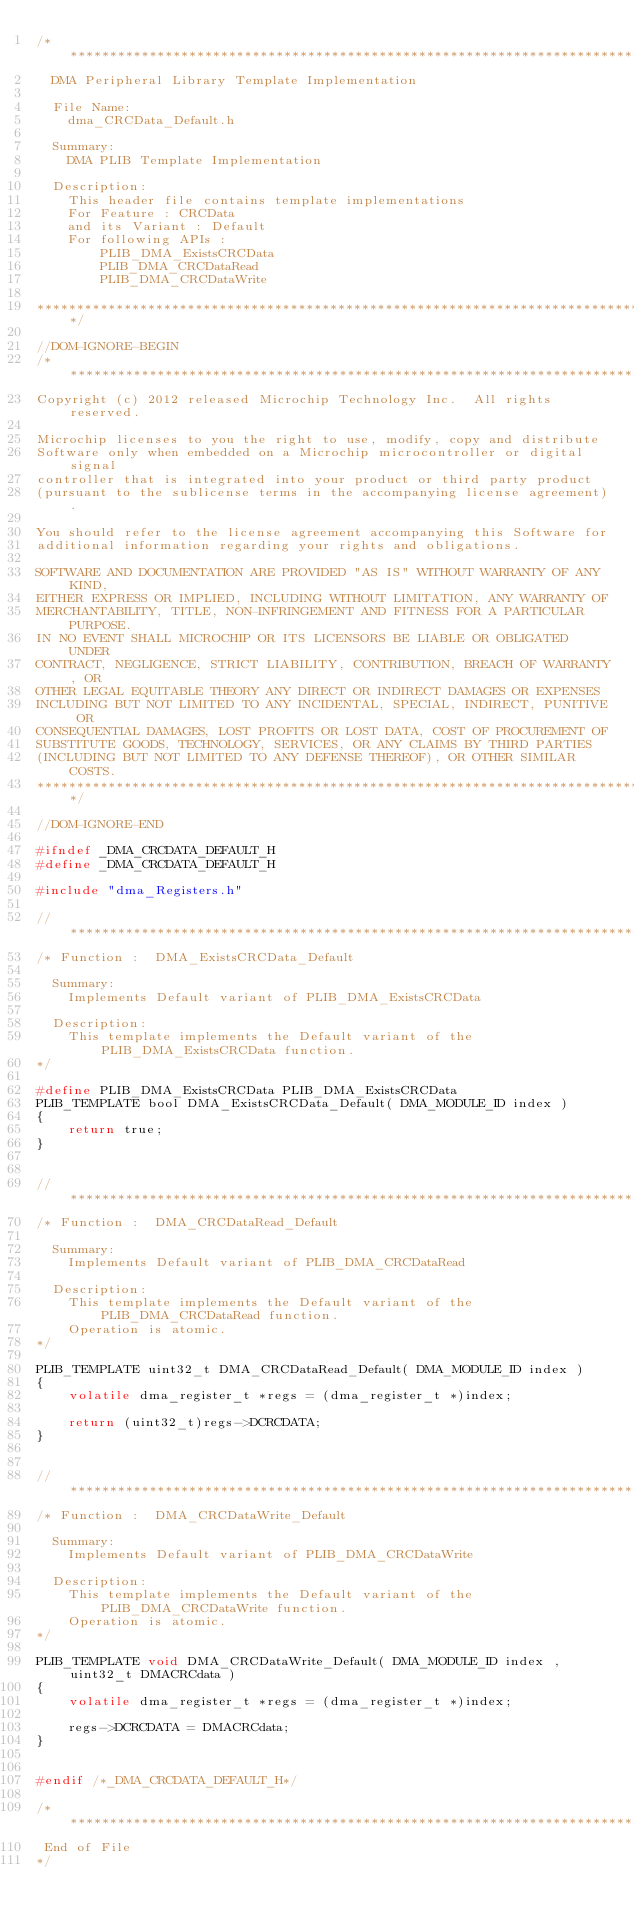Convert code to text. <code><loc_0><loc_0><loc_500><loc_500><_C_>/*******************************************************************************
  DMA Peripheral Library Template Implementation

  File Name:
    dma_CRCData_Default.h

  Summary:
    DMA PLIB Template Implementation

  Description:
    This header file contains template implementations
    For Feature : CRCData
    and its Variant : Default
    For following APIs :
        PLIB_DMA_ExistsCRCData
        PLIB_DMA_CRCDataRead
        PLIB_DMA_CRCDataWrite

*******************************************************************************/

//DOM-IGNORE-BEGIN
/*******************************************************************************
Copyright (c) 2012 released Microchip Technology Inc.  All rights reserved.

Microchip licenses to you the right to use, modify, copy and distribute
Software only when embedded on a Microchip microcontroller or digital signal
controller that is integrated into your product or third party product
(pursuant to the sublicense terms in the accompanying license agreement).

You should refer to the license agreement accompanying this Software for
additional information regarding your rights and obligations.

SOFTWARE AND DOCUMENTATION ARE PROVIDED "AS IS" WITHOUT WARRANTY OF ANY KIND,
EITHER EXPRESS OR IMPLIED, INCLUDING WITHOUT LIMITATION, ANY WARRANTY OF
MERCHANTABILITY, TITLE, NON-INFRINGEMENT AND FITNESS FOR A PARTICULAR PURPOSE.
IN NO EVENT SHALL MICROCHIP OR ITS LICENSORS BE LIABLE OR OBLIGATED UNDER
CONTRACT, NEGLIGENCE, STRICT LIABILITY, CONTRIBUTION, BREACH OF WARRANTY, OR
OTHER LEGAL EQUITABLE THEORY ANY DIRECT OR INDIRECT DAMAGES OR EXPENSES
INCLUDING BUT NOT LIMITED TO ANY INCIDENTAL, SPECIAL, INDIRECT, PUNITIVE OR
CONSEQUENTIAL DAMAGES, LOST PROFITS OR LOST DATA, COST OF PROCUREMENT OF
SUBSTITUTE GOODS, TECHNOLOGY, SERVICES, OR ANY CLAIMS BY THIRD PARTIES
(INCLUDING BUT NOT LIMITED TO ANY DEFENSE THEREOF), OR OTHER SIMILAR COSTS.
*******************************************************************************/

//DOM-IGNORE-END

#ifndef _DMA_CRCDATA_DEFAULT_H
#define _DMA_CRCDATA_DEFAULT_H

#include "dma_Registers.h"

//******************************************************************************
/* Function :  DMA_ExistsCRCData_Default

  Summary:
    Implements Default variant of PLIB_DMA_ExistsCRCData

  Description:
    This template implements the Default variant of the PLIB_DMA_ExistsCRCData function.
*/

#define PLIB_DMA_ExistsCRCData PLIB_DMA_ExistsCRCData
PLIB_TEMPLATE bool DMA_ExistsCRCData_Default( DMA_MODULE_ID index )
{
    return true;
}


//******************************************************************************
/* Function :  DMA_CRCDataRead_Default

  Summary:
    Implements Default variant of PLIB_DMA_CRCDataRead

  Description:
    This template implements the Default variant of the PLIB_DMA_CRCDataRead function.
    Operation is atomic.
*/

PLIB_TEMPLATE uint32_t DMA_CRCDataRead_Default( DMA_MODULE_ID index )
{
    volatile dma_register_t *regs = (dma_register_t *)index;

    return (uint32_t)regs->DCRCDATA;
}


//******************************************************************************
/* Function :  DMA_CRCDataWrite_Default

  Summary:
    Implements Default variant of PLIB_DMA_CRCDataWrite

  Description:
    This template implements the Default variant of the PLIB_DMA_CRCDataWrite function.
    Operation is atomic.
*/

PLIB_TEMPLATE void DMA_CRCDataWrite_Default( DMA_MODULE_ID index , uint32_t DMACRCdata )
{
    volatile dma_register_t *regs = (dma_register_t *)index;

    regs->DCRCDATA = DMACRCdata;
}


#endif /*_DMA_CRCDATA_DEFAULT_H*/

/******************************************************************************
 End of File
*/

</code> 